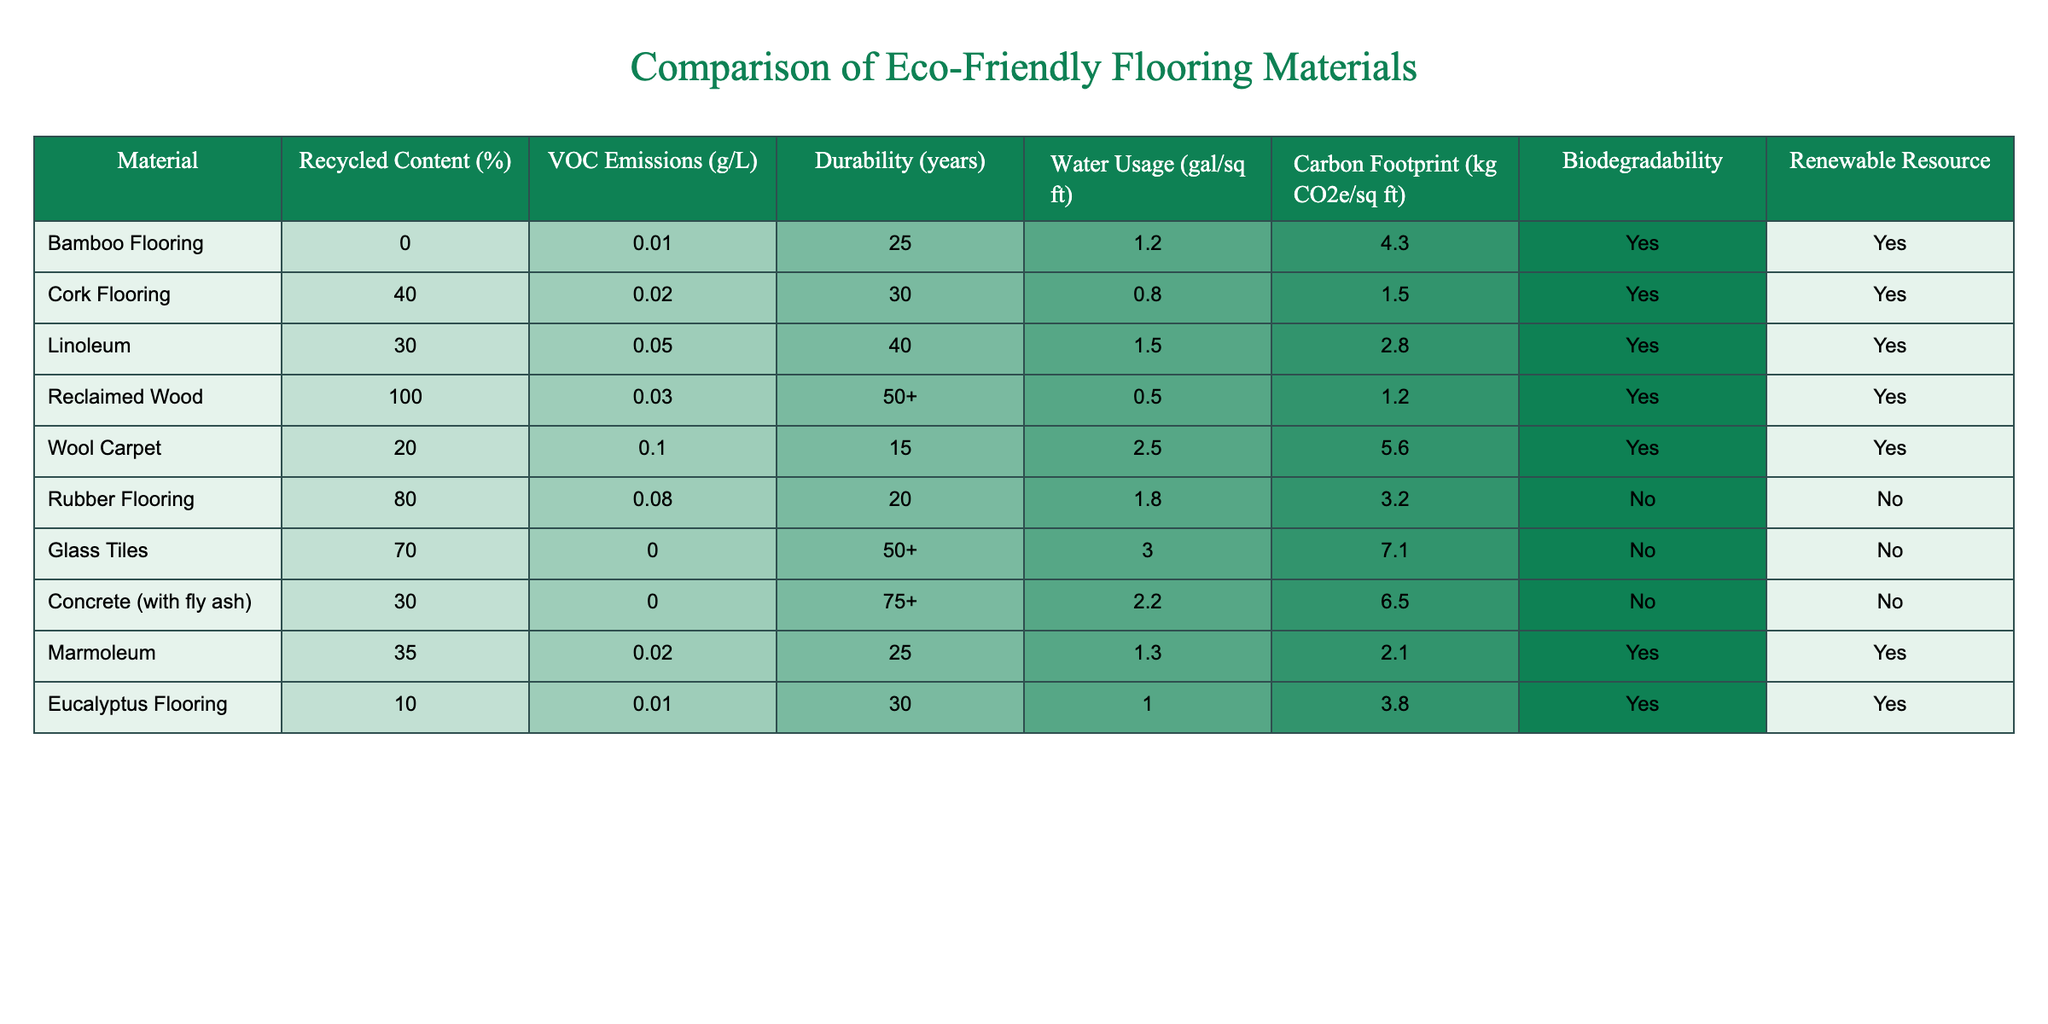What is the recycled content percentage of Reclaimed Wood? The data shows that Reclaimed Wood has a recycled content of 100%.
Answer: 100% Which material has the highest durability in years? Looking at the durability column, Glass Tiles and Concrete (with fly ash) both have a durability of 50+ years, which is the highest among all materials listed.
Answer: 50+ What is the water usage for Cork Flooring? The table indicates that Cork Flooring has a water usage of 0.8 gallons per square foot.
Answer: 0.8 Is Rubber Flooring biodegradable? According to the biodegradable column, Rubber Flooring is marked as "No," meaning it is not biodegradable.
Answer: No Calculate the average carbon footprint for the materials listed. Adding the carbon footprint values: (4.3 + 1.5 + 2.8 + 1.2 + 5.6 + 3.2 + 7.1 + 6.5 + 2.1 + 3.8) equals 34.1. There are 10 materials, so the average is 34.1 / 10 = 3.41 kg CO2e/sq ft.
Answer: 3.41 Which material has the lowest VOC emissions? The table indicates that Bamboo Flooring has the lowest VOC emissions, reported as 0.01 g/L.
Answer: 0.01 How many materials use renewable resources? Looking at the renewable resource column, we see that Bamboo Flooring, Cork Flooring, Linoleum, Reclaimed Wood, Wool Carpet, and Eucalyptus Flooring are marked as "Yes," totaling 6 materials.
Answer: 6 What is the difference in durability between Linoleum and Wool Carpet? Linoleum has a durability of 40 years, while Wool Carpet has a durability of 15 years. The difference in durability is 40 - 15 = 25 years.
Answer: 25 Is there any flooring material that has a carbon footprint below 2 kg CO2e/sq ft? By examining the carbon footprint column, we find that Cork Flooring (1.5) and Reclaimed Wood (1.2) have carbon footprints below 2 kg CO2e/sq ft, confirming that yes, there are materials that meet this criterion.
Answer: Yes 